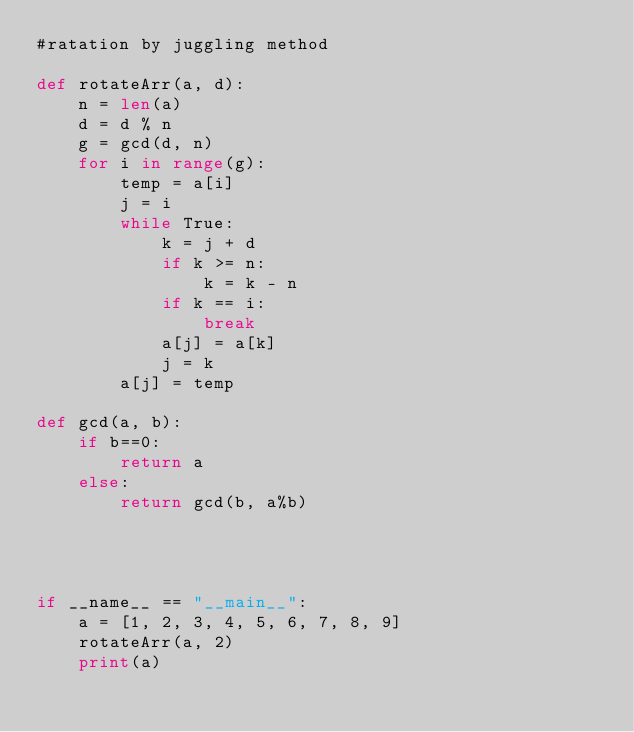<code> <loc_0><loc_0><loc_500><loc_500><_Python_>#ratation by juggling method

def rotateArr(a, d):
    n = len(a)
    d = d % n
    g = gcd(d, n)
    for i in range(g):
        temp = a[i]
        j = i
        while True:
            k = j + d   
            if k >= n:
                k = k - n
            if k == i:
                break
            a[j] = a[k]
            j = k
        a[j] = temp

def gcd(a, b):
    if b==0:
        return a
    else:
        return gcd(b, a%b)
            



if __name__ == "__main__":
    a = [1, 2, 3, 4, 5, 6, 7, 8, 9]
    rotateArr(a, 2)
    print(a)</code> 